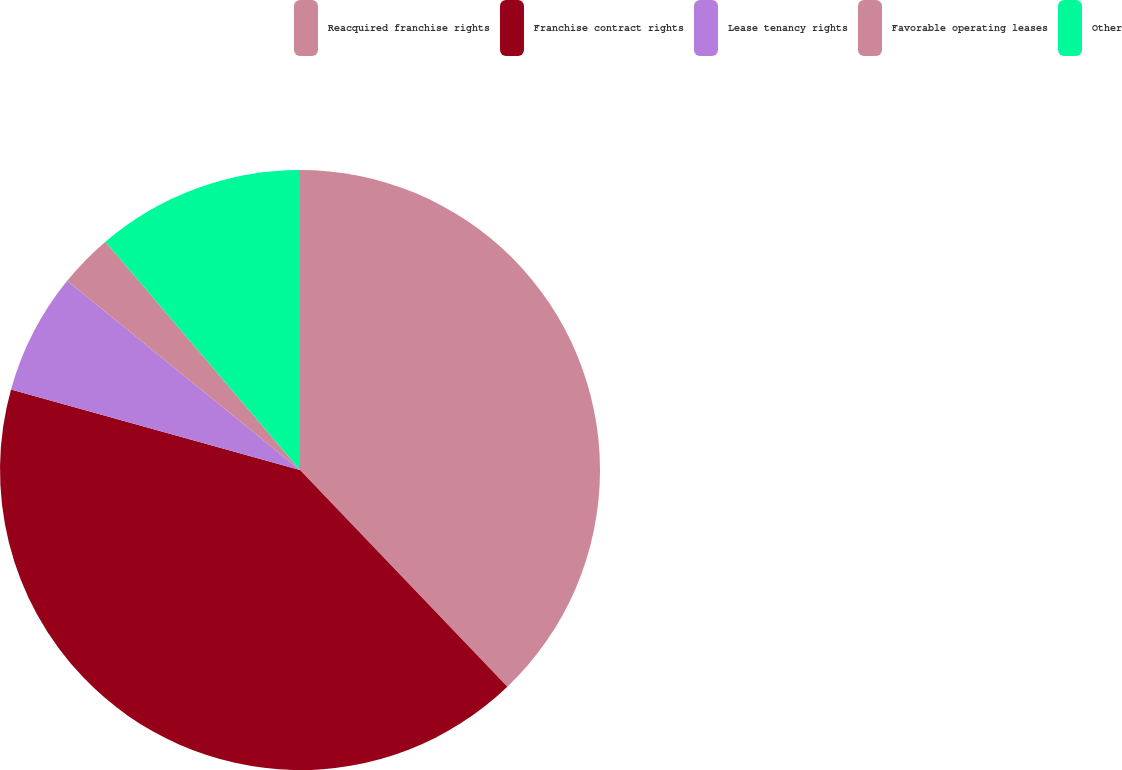Convert chart to OTSL. <chart><loc_0><loc_0><loc_500><loc_500><pie_chart><fcel>Reacquired franchise rights<fcel>Franchise contract rights<fcel>Lease tenancy rights<fcel>Favorable operating leases<fcel>Other<nl><fcel>37.85%<fcel>41.47%<fcel>6.53%<fcel>2.91%<fcel>11.23%<nl></chart> 